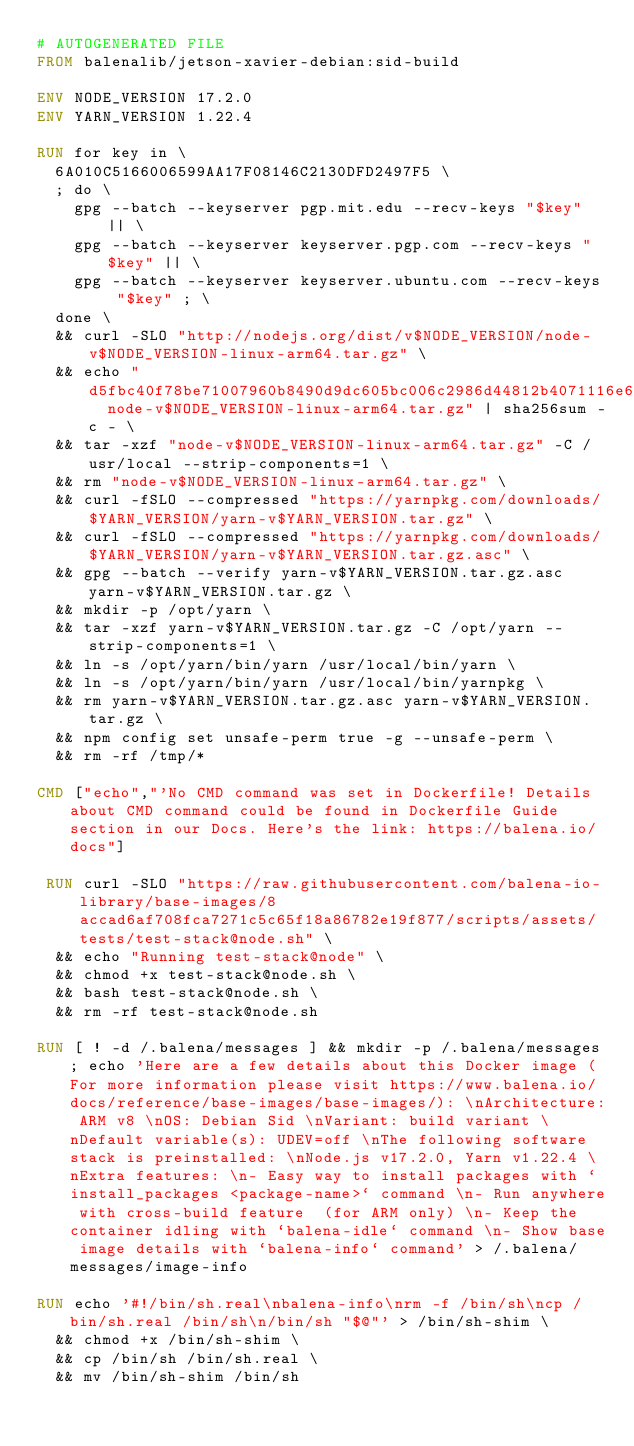<code> <loc_0><loc_0><loc_500><loc_500><_Dockerfile_># AUTOGENERATED FILE
FROM balenalib/jetson-xavier-debian:sid-build

ENV NODE_VERSION 17.2.0
ENV YARN_VERSION 1.22.4

RUN for key in \
	6A010C5166006599AA17F08146C2130DFD2497F5 \
	; do \
		gpg --batch --keyserver pgp.mit.edu --recv-keys "$key" || \
		gpg --batch --keyserver keyserver.pgp.com --recv-keys "$key" || \
		gpg --batch --keyserver keyserver.ubuntu.com --recv-keys "$key" ; \
	done \
	&& curl -SLO "http://nodejs.org/dist/v$NODE_VERSION/node-v$NODE_VERSION-linux-arm64.tar.gz" \
	&& echo "d5fbc40f78be71007960b8490d9dc605bc006c2986d44812b4071116e6499ca4  node-v$NODE_VERSION-linux-arm64.tar.gz" | sha256sum -c - \
	&& tar -xzf "node-v$NODE_VERSION-linux-arm64.tar.gz" -C /usr/local --strip-components=1 \
	&& rm "node-v$NODE_VERSION-linux-arm64.tar.gz" \
	&& curl -fSLO --compressed "https://yarnpkg.com/downloads/$YARN_VERSION/yarn-v$YARN_VERSION.tar.gz" \
	&& curl -fSLO --compressed "https://yarnpkg.com/downloads/$YARN_VERSION/yarn-v$YARN_VERSION.tar.gz.asc" \
	&& gpg --batch --verify yarn-v$YARN_VERSION.tar.gz.asc yarn-v$YARN_VERSION.tar.gz \
	&& mkdir -p /opt/yarn \
	&& tar -xzf yarn-v$YARN_VERSION.tar.gz -C /opt/yarn --strip-components=1 \
	&& ln -s /opt/yarn/bin/yarn /usr/local/bin/yarn \
	&& ln -s /opt/yarn/bin/yarn /usr/local/bin/yarnpkg \
	&& rm yarn-v$YARN_VERSION.tar.gz.asc yarn-v$YARN_VERSION.tar.gz \
	&& npm config set unsafe-perm true -g --unsafe-perm \
	&& rm -rf /tmp/*

CMD ["echo","'No CMD command was set in Dockerfile! Details about CMD command could be found in Dockerfile Guide section in our Docs. Here's the link: https://balena.io/docs"]

 RUN curl -SLO "https://raw.githubusercontent.com/balena-io-library/base-images/8accad6af708fca7271c5c65f18a86782e19f877/scripts/assets/tests/test-stack@node.sh" \
  && echo "Running test-stack@node" \
  && chmod +x test-stack@node.sh \
  && bash test-stack@node.sh \
  && rm -rf test-stack@node.sh 

RUN [ ! -d /.balena/messages ] && mkdir -p /.balena/messages; echo 'Here are a few details about this Docker image (For more information please visit https://www.balena.io/docs/reference/base-images/base-images/): \nArchitecture: ARM v8 \nOS: Debian Sid \nVariant: build variant \nDefault variable(s): UDEV=off \nThe following software stack is preinstalled: \nNode.js v17.2.0, Yarn v1.22.4 \nExtra features: \n- Easy way to install packages with `install_packages <package-name>` command \n- Run anywhere with cross-build feature  (for ARM only) \n- Keep the container idling with `balena-idle` command \n- Show base image details with `balena-info` command' > /.balena/messages/image-info

RUN echo '#!/bin/sh.real\nbalena-info\nrm -f /bin/sh\ncp /bin/sh.real /bin/sh\n/bin/sh "$@"' > /bin/sh-shim \
	&& chmod +x /bin/sh-shim \
	&& cp /bin/sh /bin/sh.real \
	&& mv /bin/sh-shim /bin/sh</code> 